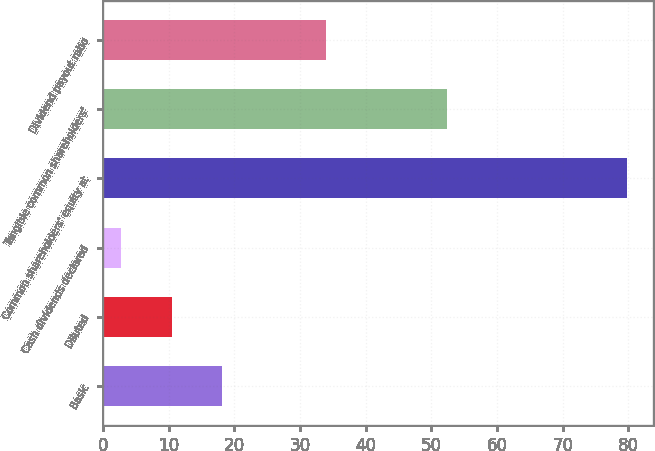Convert chart. <chart><loc_0><loc_0><loc_500><loc_500><bar_chart><fcel>Basic<fcel>Diluted<fcel>Cash dividends declared<fcel>Common shareholders' equity at<fcel>Tangible common shareholders'<fcel>Dividend payout ratio<nl><fcel>18.2<fcel>10.5<fcel>2.8<fcel>79.81<fcel>52.45<fcel>33.94<nl></chart> 